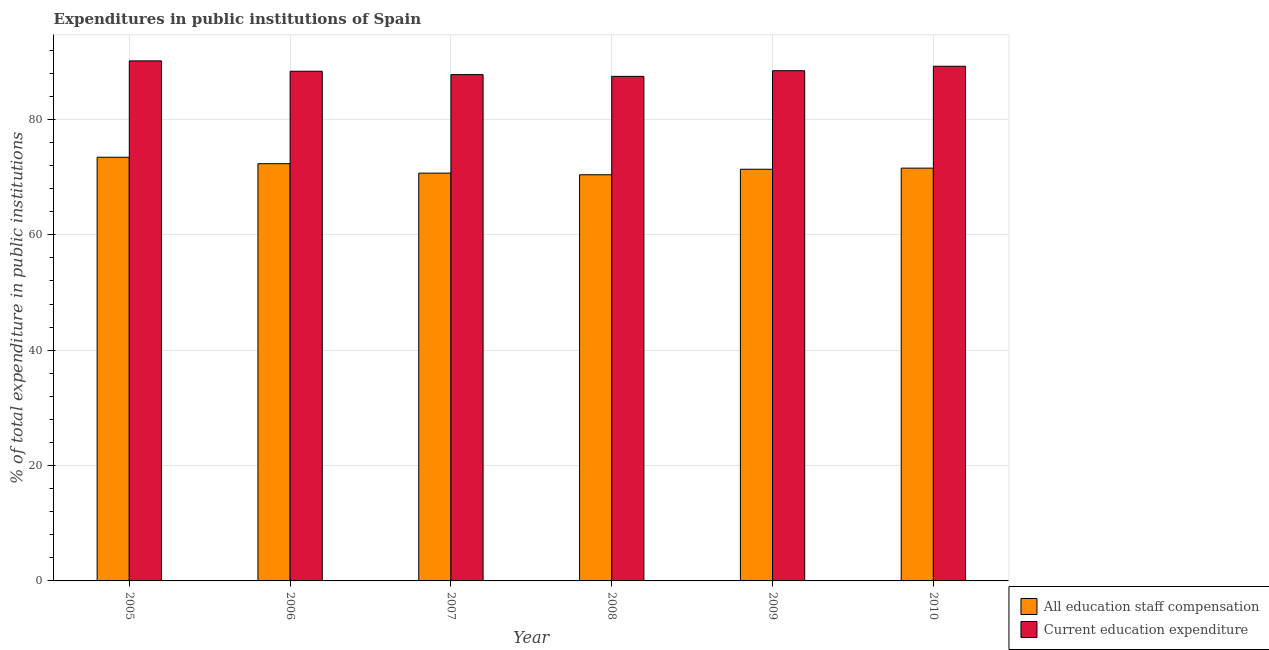How many different coloured bars are there?
Make the answer very short. 2. Are the number of bars per tick equal to the number of legend labels?
Keep it short and to the point. Yes. How many bars are there on the 2nd tick from the left?
Ensure brevity in your answer.  2. What is the label of the 1st group of bars from the left?
Provide a short and direct response. 2005. In how many cases, is the number of bars for a given year not equal to the number of legend labels?
Provide a short and direct response. 0. What is the expenditure in education in 2007?
Make the answer very short. 87.78. Across all years, what is the maximum expenditure in staff compensation?
Make the answer very short. 73.45. Across all years, what is the minimum expenditure in education?
Provide a short and direct response. 87.47. In which year was the expenditure in education minimum?
Make the answer very short. 2008. What is the total expenditure in staff compensation in the graph?
Your answer should be very brief. 429.83. What is the difference between the expenditure in staff compensation in 2005 and that in 2010?
Give a very brief answer. 1.89. What is the difference between the expenditure in education in 2010 and the expenditure in staff compensation in 2009?
Your response must be concise. 0.77. What is the average expenditure in staff compensation per year?
Make the answer very short. 71.64. In how many years, is the expenditure in staff compensation greater than 36 %?
Give a very brief answer. 6. What is the ratio of the expenditure in staff compensation in 2006 to that in 2007?
Make the answer very short. 1.02. Is the expenditure in staff compensation in 2007 less than that in 2009?
Provide a short and direct response. Yes. Is the difference between the expenditure in staff compensation in 2007 and 2008 greater than the difference between the expenditure in education in 2007 and 2008?
Your answer should be very brief. No. What is the difference between the highest and the second highest expenditure in education?
Ensure brevity in your answer.  0.93. What is the difference between the highest and the lowest expenditure in staff compensation?
Offer a terse response. 3.04. In how many years, is the expenditure in education greater than the average expenditure in education taken over all years?
Your response must be concise. 2. What does the 1st bar from the left in 2008 represents?
Ensure brevity in your answer.  All education staff compensation. What does the 2nd bar from the right in 2009 represents?
Your answer should be compact. All education staff compensation. Are all the bars in the graph horizontal?
Provide a succinct answer. No. How many years are there in the graph?
Your answer should be compact. 6. What is the difference between two consecutive major ticks on the Y-axis?
Offer a very short reply. 20. Does the graph contain any zero values?
Make the answer very short. No. Does the graph contain grids?
Ensure brevity in your answer.  Yes. How many legend labels are there?
Give a very brief answer. 2. How are the legend labels stacked?
Your answer should be very brief. Vertical. What is the title of the graph?
Ensure brevity in your answer.  Expenditures in public institutions of Spain. What is the label or title of the Y-axis?
Make the answer very short. % of total expenditure in public institutions. What is the % of total expenditure in public institutions in All education staff compensation in 2005?
Your response must be concise. 73.45. What is the % of total expenditure in public institutions of Current education expenditure in 2005?
Make the answer very short. 90.16. What is the % of total expenditure in public institutions of All education staff compensation in 2006?
Keep it short and to the point. 72.33. What is the % of total expenditure in public institutions of Current education expenditure in 2006?
Keep it short and to the point. 88.36. What is the % of total expenditure in public institutions in All education staff compensation in 2007?
Your response must be concise. 70.7. What is the % of total expenditure in public institutions in Current education expenditure in 2007?
Give a very brief answer. 87.78. What is the % of total expenditure in public institutions of All education staff compensation in 2008?
Your answer should be very brief. 70.42. What is the % of total expenditure in public institutions in Current education expenditure in 2008?
Make the answer very short. 87.47. What is the % of total expenditure in public institutions of All education staff compensation in 2009?
Make the answer very short. 71.37. What is the % of total expenditure in public institutions in Current education expenditure in 2009?
Provide a short and direct response. 88.45. What is the % of total expenditure in public institutions in All education staff compensation in 2010?
Offer a very short reply. 71.56. What is the % of total expenditure in public institutions of Current education expenditure in 2010?
Make the answer very short. 89.23. Across all years, what is the maximum % of total expenditure in public institutions in All education staff compensation?
Provide a short and direct response. 73.45. Across all years, what is the maximum % of total expenditure in public institutions of Current education expenditure?
Ensure brevity in your answer.  90.16. Across all years, what is the minimum % of total expenditure in public institutions of All education staff compensation?
Offer a very short reply. 70.42. Across all years, what is the minimum % of total expenditure in public institutions of Current education expenditure?
Your answer should be very brief. 87.47. What is the total % of total expenditure in public institutions in All education staff compensation in the graph?
Keep it short and to the point. 429.83. What is the total % of total expenditure in public institutions of Current education expenditure in the graph?
Your answer should be very brief. 531.45. What is the difference between the % of total expenditure in public institutions of All education staff compensation in 2005 and that in 2006?
Your answer should be very brief. 1.12. What is the difference between the % of total expenditure in public institutions of Current education expenditure in 2005 and that in 2006?
Provide a short and direct response. 1.8. What is the difference between the % of total expenditure in public institutions in All education staff compensation in 2005 and that in 2007?
Make the answer very short. 2.76. What is the difference between the % of total expenditure in public institutions in Current education expenditure in 2005 and that in 2007?
Your response must be concise. 2.38. What is the difference between the % of total expenditure in public institutions of All education staff compensation in 2005 and that in 2008?
Make the answer very short. 3.04. What is the difference between the % of total expenditure in public institutions in Current education expenditure in 2005 and that in 2008?
Provide a succinct answer. 2.69. What is the difference between the % of total expenditure in public institutions in All education staff compensation in 2005 and that in 2009?
Make the answer very short. 2.08. What is the difference between the % of total expenditure in public institutions in Current education expenditure in 2005 and that in 2009?
Give a very brief answer. 1.7. What is the difference between the % of total expenditure in public institutions in All education staff compensation in 2005 and that in 2010?
Keep it short and to the point. 1.89. What is the difference between the % of total expenditure in public institutions in Current education expenditure in 2005 and that in 2010?
Offer a very short reply. 0.93. What is the difference between the % of total expenditure in public institutions in All education staff compensation in 2006 and that in 2007?
Offer a terse response. 1.64. What is the difference between the % of total expenditure in public institutions in Current education expenditure in 2006 and that in 2007?
Your answer should be very brief. 0.58. What is the difference between the % of total expenditure in public institutions of All education staff compensation in 2006 and that in 2008?
Offer a terse response. 1.92. What is the difference between the % of total expenditure in public institutions of Current education expenditure in 2006 and that in 2008?
Give a very brief answer. 0.89. What is the difference between the % of total expenditure in public institutions in All education staff compensation in 2006 and that in 2009?
Keep it short and to the point. 0.96. What is the difference between the % of total expenditure in public institutions in Current education expenditure in 2006 and that in 2009?
Keep it short and to the point. -0.09. What is the difference between the % of total expenditure in public institutions of All education staff compensation in 2006 and that in 2010?
Your answer should be compact. 0.77. What is the difference between the % of total expenditure in public institutions of Current education expenditure in 2006 and that in 2010?
Your response must be concise. -0.87. What is the difference between the % of total expenditure in public institutions in All education staff compensation in 2007 and that in 2008?
Your response must be concise. 0.28. What is the difference between the % of total expenditure in public institutions in Current education expenditure in 2007 and that in 2008?
Your answer should be compact. 0.31. What is the difference between the % of total expenditure in public institutions in All education staff compensation in 2007 and that in 2009?
Provide a succinct answer. -0.67. What is the difference between the % of total expenditure in public institutions of Current education expenditure in 2007 and that in 2009?
Provide a succinct answer. -0.68. What is the difference between the % of total expenditure in public institutions of All education staff compensation in 2007 and that in 2010?
Provide a short and direct response. -0.87. What is the difference between the % of total expenditure in public institutions in Current education expenditure in 2007 and that in 2010?
Offer a very short reply. -1.45. What is the difference between the % of total expenditure in public institutions in All education staff compensation in 2008 and that in 2009?
Your response must be concise. -0.95. What is the difference between the % of total expenditure in public institutions in Current education expenditure in 2008 and that in 2009?
Keep it short and to the point. -0.98. What is the difference between the % of total expenditure in public institutions of All education staff compensation in 2008 and that in 2010?
Provide a succinct answer. -1.15. What is the difference between the % of total expenditure in public institutions in Current education expenditure in 2008 and that in 2010?
Provide a short and direct response. -1.76. What is the difference between the % of total expenditure in public institutions in All education staff compensation in 2009 and that in 2010?
Your response must be concise. -0.19. What is the difference between the % of total expenditure in public institutions of Current education expenditure in 2009 and that in 2010?
Your answer should be compact. -0.77. What is the difference between the % of total expenditure in public institutions of All education staff compensation in 2005 and the % of total expenditure in public institutions of Current education expenditure in 2006?
Offer a terse response. -14.91. What is the difference between the % of total expenditure in public institutions in All education staff compensation in 2005 and the % of total expenditure in public institutions in Current education expenditure in 2007?
Your response must be concise. -14.32. What is the difference between the % of total expenditure in public institutions in All education staff compensation in 2005 and the % of total expenditure in public institutions in Current education expenditure in 2008?
Your response must be concise. -14.02. What is the difference between the % of total expenditure in public institutions of All education staff compensation in 2005 and the % of total expenditure in public institutions of Current education expenditure in 2009?
Give a very brief answer. -15. What is the difference between the % of total expenditure in public institutions of All education staff compensation in 2005 and the % of total expenditure in public institutions of Current education expenditure in 2010?
Your answer should be very brief. -15.78. What is the difference between the % of total expenditure in public institutions of All education staff compensation in 2006 and the % of total expenditure in public institutions of Current education expenditure in 2007?
Provide a succinct answer. -15.44. What is the difference between the % of total expenditure in public institutions of All education staff compensation in 2006 and the % of total expenditure in public institutions of Current education expenditure in 2008?
Offer a terse response. -15.14. What is the difference between the % of total expenditure in public institutions in All education staff compensation in 2006 and the % of total expenditure in public institutions in Current education expenditure in 2009?
Your answer should be compact. -16.12. What is the difference between the % of total expenditure in public institutions of All education staff compensation in 2006 and the % of total expenditure in public institutions of Current education expenditure in 2010?
Provide a short and direct response. -16.89. What is the difference between the % of total expenditure in public institutions in All education staff compensation in 2007 and the % of total expenditure in public institutions in Current education expenditure in 2008?
Provide a succinct answer. -16.78. What is the difference between the % of total expenditure in public institutions of All education staff compensation in 2007 and the % of total expenditure in public institutions of Current education expenditure in 2009?
Keep it short and to the point. -17.76. What is the difference between the % of total expenditure in public institutions of All education staff compensation in 2007 and the % of total expenditure in public institutions of Current education expenditure in 2010?
Keep it short and to the point. -18.53. What is the difference between the % of total expenditure in public institutions of All education staff compensation in 2008 and the % of total expenditure in public institutions of Current education expenditure in 2009?
Your response must be concise. -18.04. What is the difference between the % of total expenditure in public institutions of All education staff compensation in 2008 and the % of total expenditure in public institutions of Current education expenditure in 2010?
Offer a terse response. -18.81. What is the difference between the % of total expenditure in public institutions of All education staff compensation in 2009 and the % of total expenditure in public institutions of Current education expenditure in 2010?
Make the answer very short. -17.86. What is the average % of total expenditure in public institutions of All education staff compensation per year?
Ensure brevity in your answer.  71.64. What is the average % of total expenditure in public institutions of Current education expenditure per year?
Your answer should be compact. 88.57. In the year 2005, what is the difference between the % of total expenditure in public institutions in All education staff compensation and % of total expenditure in public institutions in Current education expenditure?
Keep it short and to the point. -16.71. In the year 2006, what is the difference between the % of total expenditure in public institutions in All education staff compensation and % of total expenditure in public institutions in Current education expenditure?
Ensure brevity in your answer.  -16.03. In the year 2007, what is the difference between the % of total expenditure in public institutions in All education staff compensation and % of total expenditure in public institutions in Current education expenditure?
Offer a terse response. -17.08. In the year 2008, what is the difference between the % of total expenditure in public institutions of All education staff compensation and % of total expenditure in public institutions of Current education expenditure?
Offer a terse response. -17.06. In the year 2009, what is the difference between the % of total expenditure in public institutions of All education staff compensation and % of total expenditure in public institutions of Current education expenditure?
Your answer should be compact. -17.08. In the year 2010, what is the difference between the % of total expenditure in public institutions of All education staff compensation and % of total expenditure in public institutions of Current education expenditure?
Offer a very short reply. -17.67. What is the ratio of the % of total expenditure in public institutions of All education staff compensation in 2005 to that in 2006?
Your answer should be very brief. 1.02. What is the ratio of the % of total expenditure in public institutions of Current education expenditure in 2005 to that in 2006?
Make the answer very short. 1.02. What is the ratio of the % of total expenditure in public institutions of All education staff compensation in 2005 to that in 2007?
Provide a short and direct response. 1.04. What is the ratio of the % of total expenditure in public institutions of Current education expenditure in 2005 to that in 2007?
Your response must be concise. 1.03. What is the ratio of the % of total expenditure in public institutions of All education staff compensation in 2005 to that in 2008?
Keep it short and to the point. 1.04. What is the ratio of the % of total expenditure in public institutions of Current education expenditure in 2005 to that in 2008?
Give a very brief answer. 1.03. What is the ratio of the % of total expenditure in public institutions of All education staff compensation in 2005 to that in 2009?
Give a very brief answer. 1.03. What is the ratio of the % of total expenditure in public institutions in Current education expenditure in 2005 to that in 2009?
Give a very brief answer. 1.02. What is the ratio of the % of total expenditure in public institutions of All education staff compensation in 2005 to that in 2010?
Your answer should be compact. 1.03. What is the ratio of the % of total expenditure in public institutions in Current education expenditure in 2005 to that in 2010?
Keep it short and to the point. 1.01. What is the ratio of the % of total expenditure in public institutions in All education staff compensation in 2006 to that in 2007?
Keep it short and to the point. 1.02. What is the ratio of the % of total expenditure in public institutions in Current education expenditure in 2006 to that in 2007?
Ensure brevity in your answer.  1.01. What is the ratio of the % of total expenditure in public institutions in All education staff compensation in 2006 to that in 2008?
Give a very brief answer. 1.03. What is the ratio of the % of total expenditure in public institutions of Current education expenditure in 2006 to that in 2008?
Your answer should be compact. 1.01. What is the ratio of the % of total expenditure in public institutions of All education staff compensation in 2006 to that in 2009?
Make the answer very short. 1.01. What is the ratio of the % of total expenditure in public institutions in Current education expenditure in 2006 to that in 2009?
Your answer should be compact. 1. What is the ratio of the % of total expenditure in public institutions of All education staff compensation in 2006 to that in 2010?
Give a very brief answer. 1.01. What is the ratio of the % of total expenditure in public institutions in Current education expenditure in 2006 to that in 2010?
Provide a short and direct response. 0.99. What is the ratio of the % of total expenditure in public institutions of All education staff compensation in 2007 to that in 2008?
Your answer should be very brief. 1. What is the ratio of the % of total expenditure in public institutions of Current education expenditure in 2007 to that in 2008?
Ensure brevity in your answer.  1. What is the ratio of the % of total expenditure in public institutions of All education staff compensation in 2007 to that in 2009?
Offer a terse response. 0.99. What is the ratio of the % of total expenditure in public institutions of Current education expenditure in 2007 to that in 2009?
Provide a succinct answer. 0.99. What is the ratio of the % of total expenditure in public institutions in All education staff compensation in 2007 to that in 2010?
Your response must be concise. 0.99. What is the ratio of the % of total expenditure in public institutions in Current education expenditure in 2007 to that in 2010?
Keep it short and to the point. 0.98. What is the ratio of the % of total expenditure in public institutions in All education staff compensation in 2008 to that in 2009?
Provide a succinct answer. 0.99. What is the ratio of the % of total expenditure in public institutions in Current education expenditure in 2008 to that in 2009?
Your answer should be very brief. 0.99. What is the ratio of the % of total expenditure in public institutions in All education staff compensation in 2008 to that in 2010?
Give a very brief answer. 0.98. What is the ratio of the % of total expenditure in public institutions in Current education expenditure in 2008 to that in 2010?
Provide a succinct answer. 0.98. What is the ratio of the % of total expenditure in public institutions of All education staff compensation in 2009 to that in 2010?
Your response must be concise. 1. What is the difference between the highest and the second highest % of total expenditure in public institutions in All education staff compensation?
Make the answer very short. 1.12. What is the difference between the highest and the second highest % of total expenditure in public institutions in Current education expenditure?
Your answer should be very brief. 0.93. What is the difference between the highest and the lowest % of total expenditure in public institutions of All education staff compensation?
Your answer should be compact. 3.04. What is the difference between the highest and the lowest % of total expenditure in public institutions of Current education expenditure?
Offer a terse response. 2.69. 